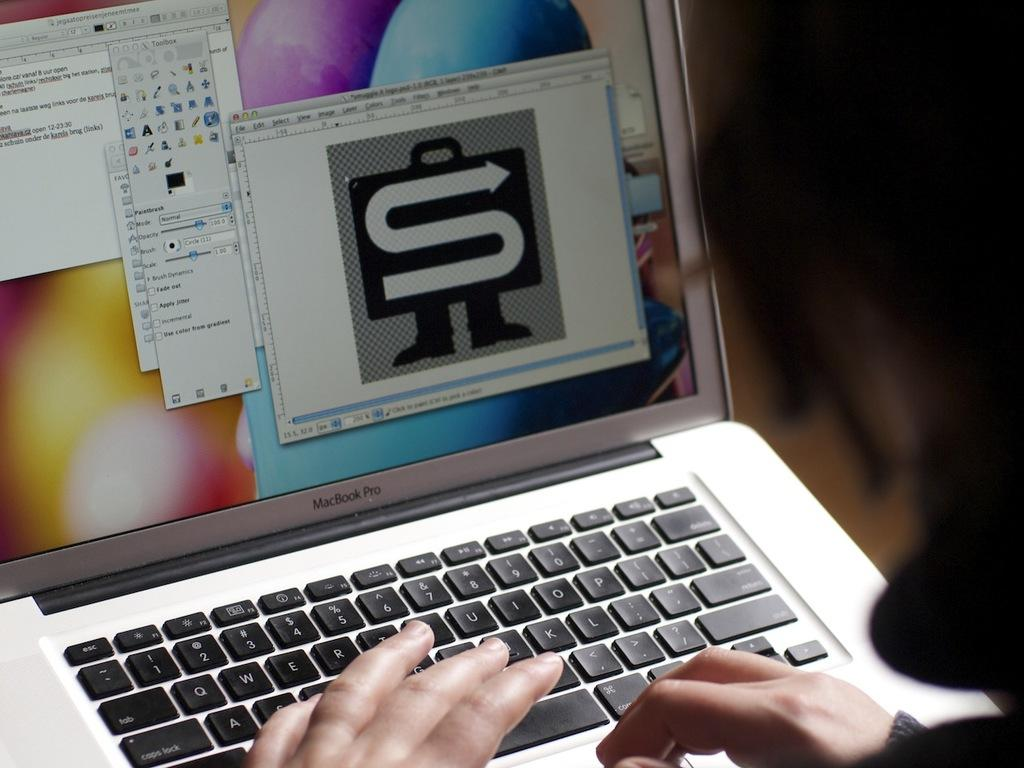Provide a one-sentence caption for the provided image. A MacBrook Pro laptop open with graphics and screens open on the display. 